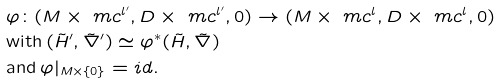<formula> <loc_0><loc_0><loc_500><loc_500>& \varphi \colon ( M \times \ m c ^ { l ^ { \prime } } , D \times \ m c ^ { l ^ { \prime } } , 0 ) \rightarrow ( M \times \ m c ^ { l } , D \times \ m c ^ { l } , 0 ) \\ & \text {with} \, ( \tilde { H } ^ { \prime } , \tilde { \nabla } ^ { \prime } ) \simeq \varphi ^ { \ast } ( \tilde { H } , \tilde { \nabla } ) \\ & \text {and} \, \varphi | _ { M \times \{ 0 \} } = i d .</formula> 